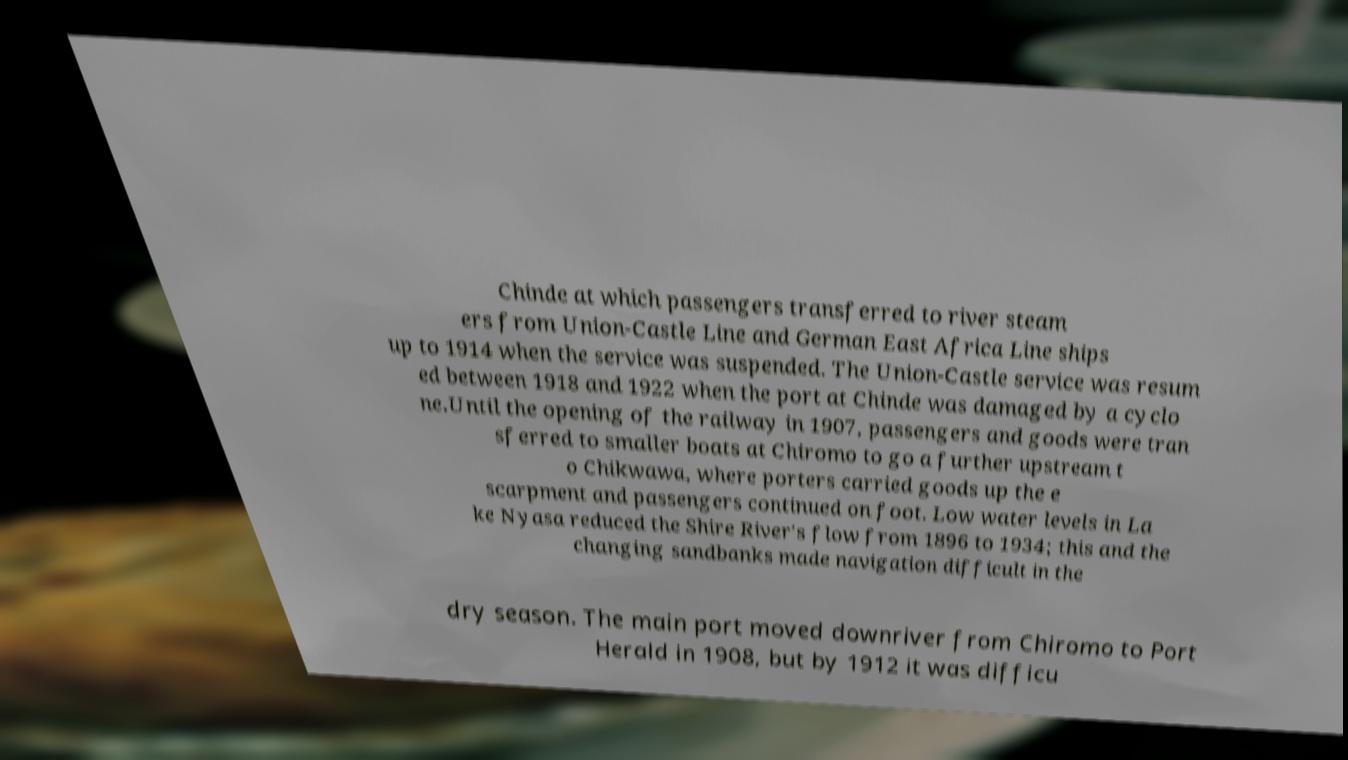Please read and relay the text visible in this image. What does it say? Chinde at which passengers transferred to river steam ers from Union-Castle Line and German East Africa Line ships up to 1914 when the service was suspended. The Union-Castle service was resum ed between 1918 and 1922 when the port at Chinde was damaged by a cyclo ne.Until the opening of the railway in 1907, passengers and goods were tran sferred to smaller boats at Chiromo to go a further upstream t o Chikwawa, where porters carried goods up the e scarpment and passengers continued on foot. Low water levels in La ke Nyasa reduced the Shire River's flow from 1896 to 1934; this and the changing sandbanks made navigation difficult in the dry season. The main port moved downriver from Chiromo to Port Herald in 1908, but by 1912 it was difficu 